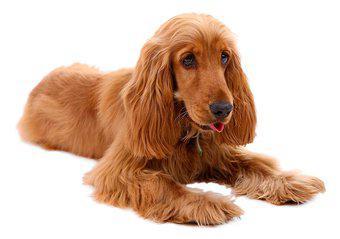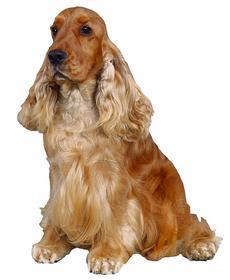The first image is the image on the left, the second image is the image on the right. Considering the images on both sides, is "A dog has its tongue sticking out." valid? Answer yes or no. Yes. The first image is the image on the left, the second image is the image on the right. For the images displayed, is the sentence "The dog in the image on the right is sitting down" factually correct? Answer yes or no. Yes. 